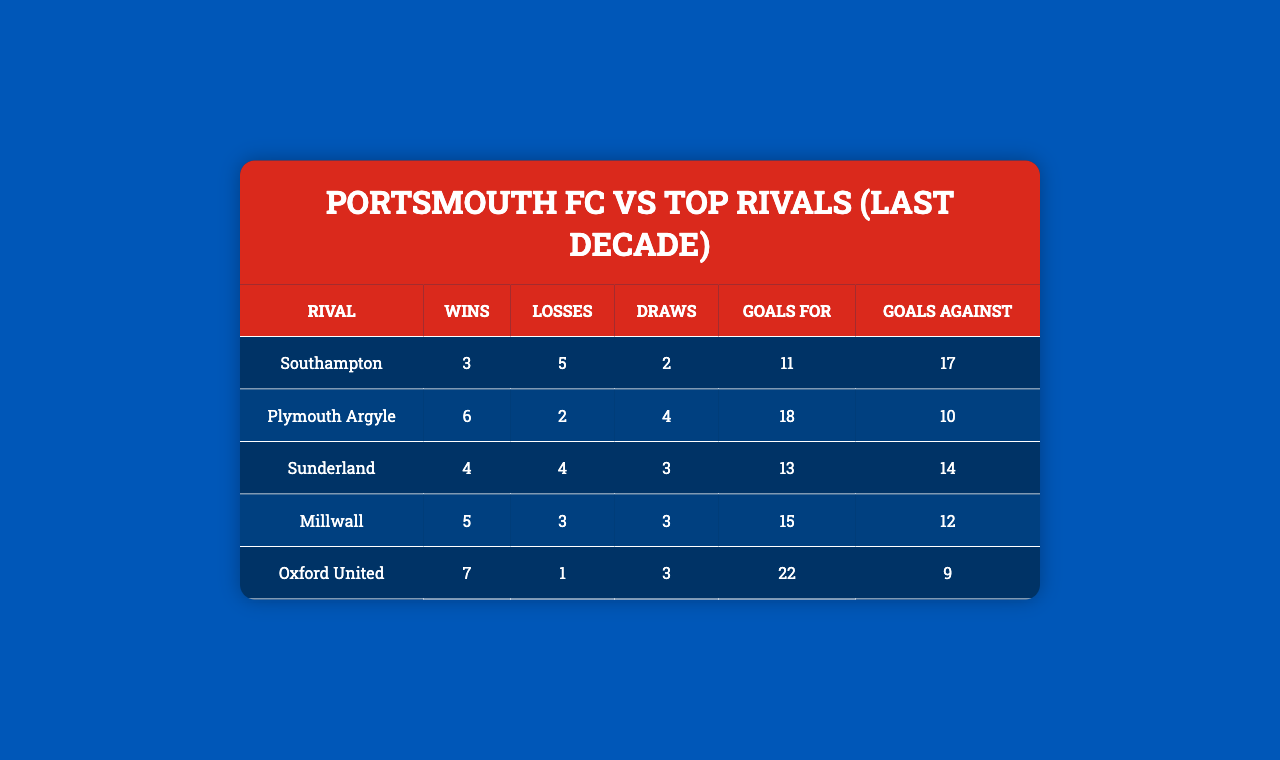What is Portsmouth FC's win record against Southampton? The table states that Portsmouth FC has 3 wins against Southampton.
Answer: 3 How many total matches did Portsmouth play against Oxford United? To find the total matches, add wins, losses, and draws: 7 + 1 + 3 = 11.
Answer: 11 Did Portsmouth FC win more matches against Plymouth Argyle than they lost? Portsmouth has 6 wins and 2 losses against Plymouth Argyle, which means they did win more matches.
Answer: Yes What is the goal difference for Portsmouth FC in their matches against Millwall? The goal difference is calculated by subtracting Goals Against from Goals For: 15 (Goals For) - 12 (Goals Against) = 3.
Answer: 3 Against which rival did Portsmouth FC achieve their highest number of wins? Portsmouth FC achieved the highest number of wins (7) against Oxford United.
Answer: Oxford United What is the average number of goals scored by Portsmouth against Sunderland? To find the average, take the total goals scored (13) and divide by the number of matches played (4 wins + 4 losses + 3 draws = 11): 13/11 = 1.18.
Answer: 1.18 How many draws did Portsmouth FC have against their rivals overall? To find the total number of draws, sum up all the draws: 2 (Southampton) + 4 (Plymouth Argyle) + 3 (Sunderland) + 3 (Millwall) + 3 (Oxford United) = 15.
Answer: 15 Which rival did Portsmouth FC have the best points ratio against? The best points ratio can be calculated from the wins: against Oxford United (7 wins, 1 loss, 3 draws), which means a high win rate compared to others.
Answer: Oxford United How many more goals did Portsmouth score than they conceded against Plymouth Argyle? Calculate the difference: Goals For (18) - Goals Against (10) = 8 goals more scored than conceded.
Answer: 8 Is it true that Portsmouth FC has a better win-loss record against Plymouth Argyle than against Millwall? Portsmouth has 6 wins and 2 losses against Plymouth Argyle, while they have 5 wins and 3 losses against Millwall. Since 6 > 5 and 2 < 3, they have a better record against Plymouth Argyle.
Answer: Yes 